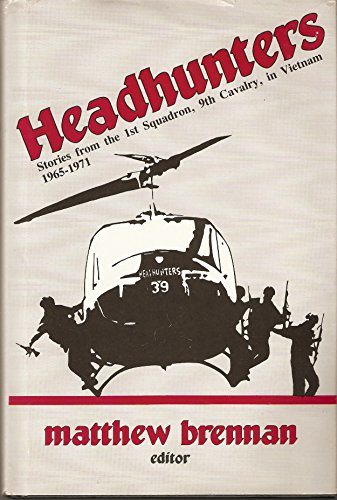Can you tell me more about the significance of the 1st Squadron, 9th Cavalry during the Vietnam War? The 1st Squadron, 9th Cavalry was a key air reconnaissance unit in the U.S. Army during the Vietnam War. Known as the 'Headhunters,' they played a crucial role in gathering intelligence and conducting rapid, aerial combat operations, which were vital for the success of ground troops. 